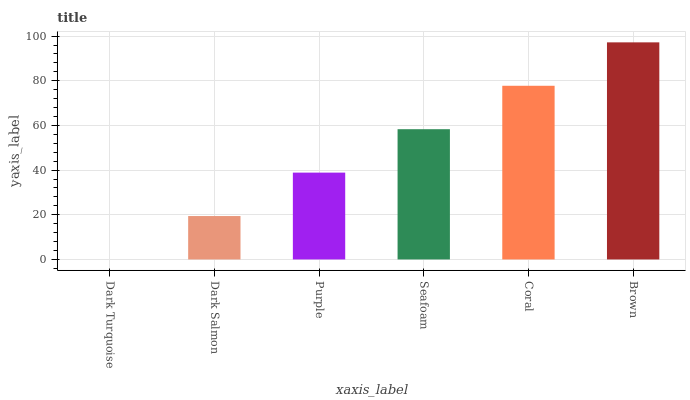Is Dark Turquoise the minimum?
Answer yes or no. Yes. Is Brown the maximum?
Answer yes or no. Yes. Is Dark Salmon the minimum?
Answer yes or no. No. Is Dark Salmon the maximum?
Answer yes or no. No. Is Dark Salmon greater than Dark Turquoise?
Answer yes or no. Yes. Is Dark Turquoise less than Dark Salmon?
Answer yes or no. Yes. Is Dark Turquoise greater than Dark Salmon?
Answer yes or no. No. Is Dark Salmon less than Dark Turquoise?
Answer yes or no. No. Is Seafoam the high median?
Answer yes or no. Yes. Is Purple the low median?
Answer yes or no. Yes. Is Brown the high median?
Answer yes or no. No. Is Brown the low median?
Answer yes or no. No. 